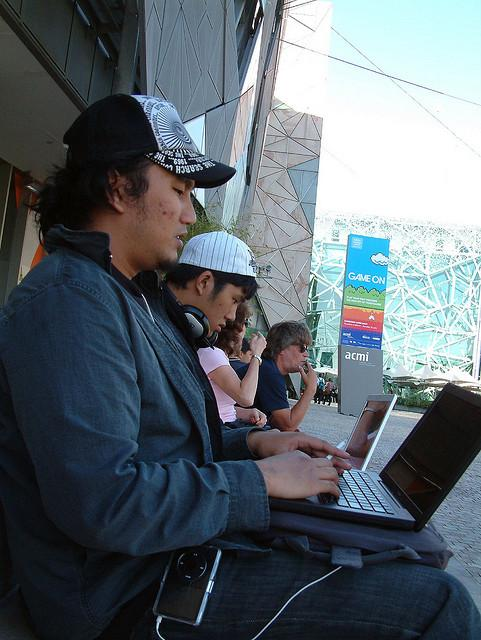What race is the man closest to the camera?

Choices:
A) black
B) asian
C) white
D) indian asian 